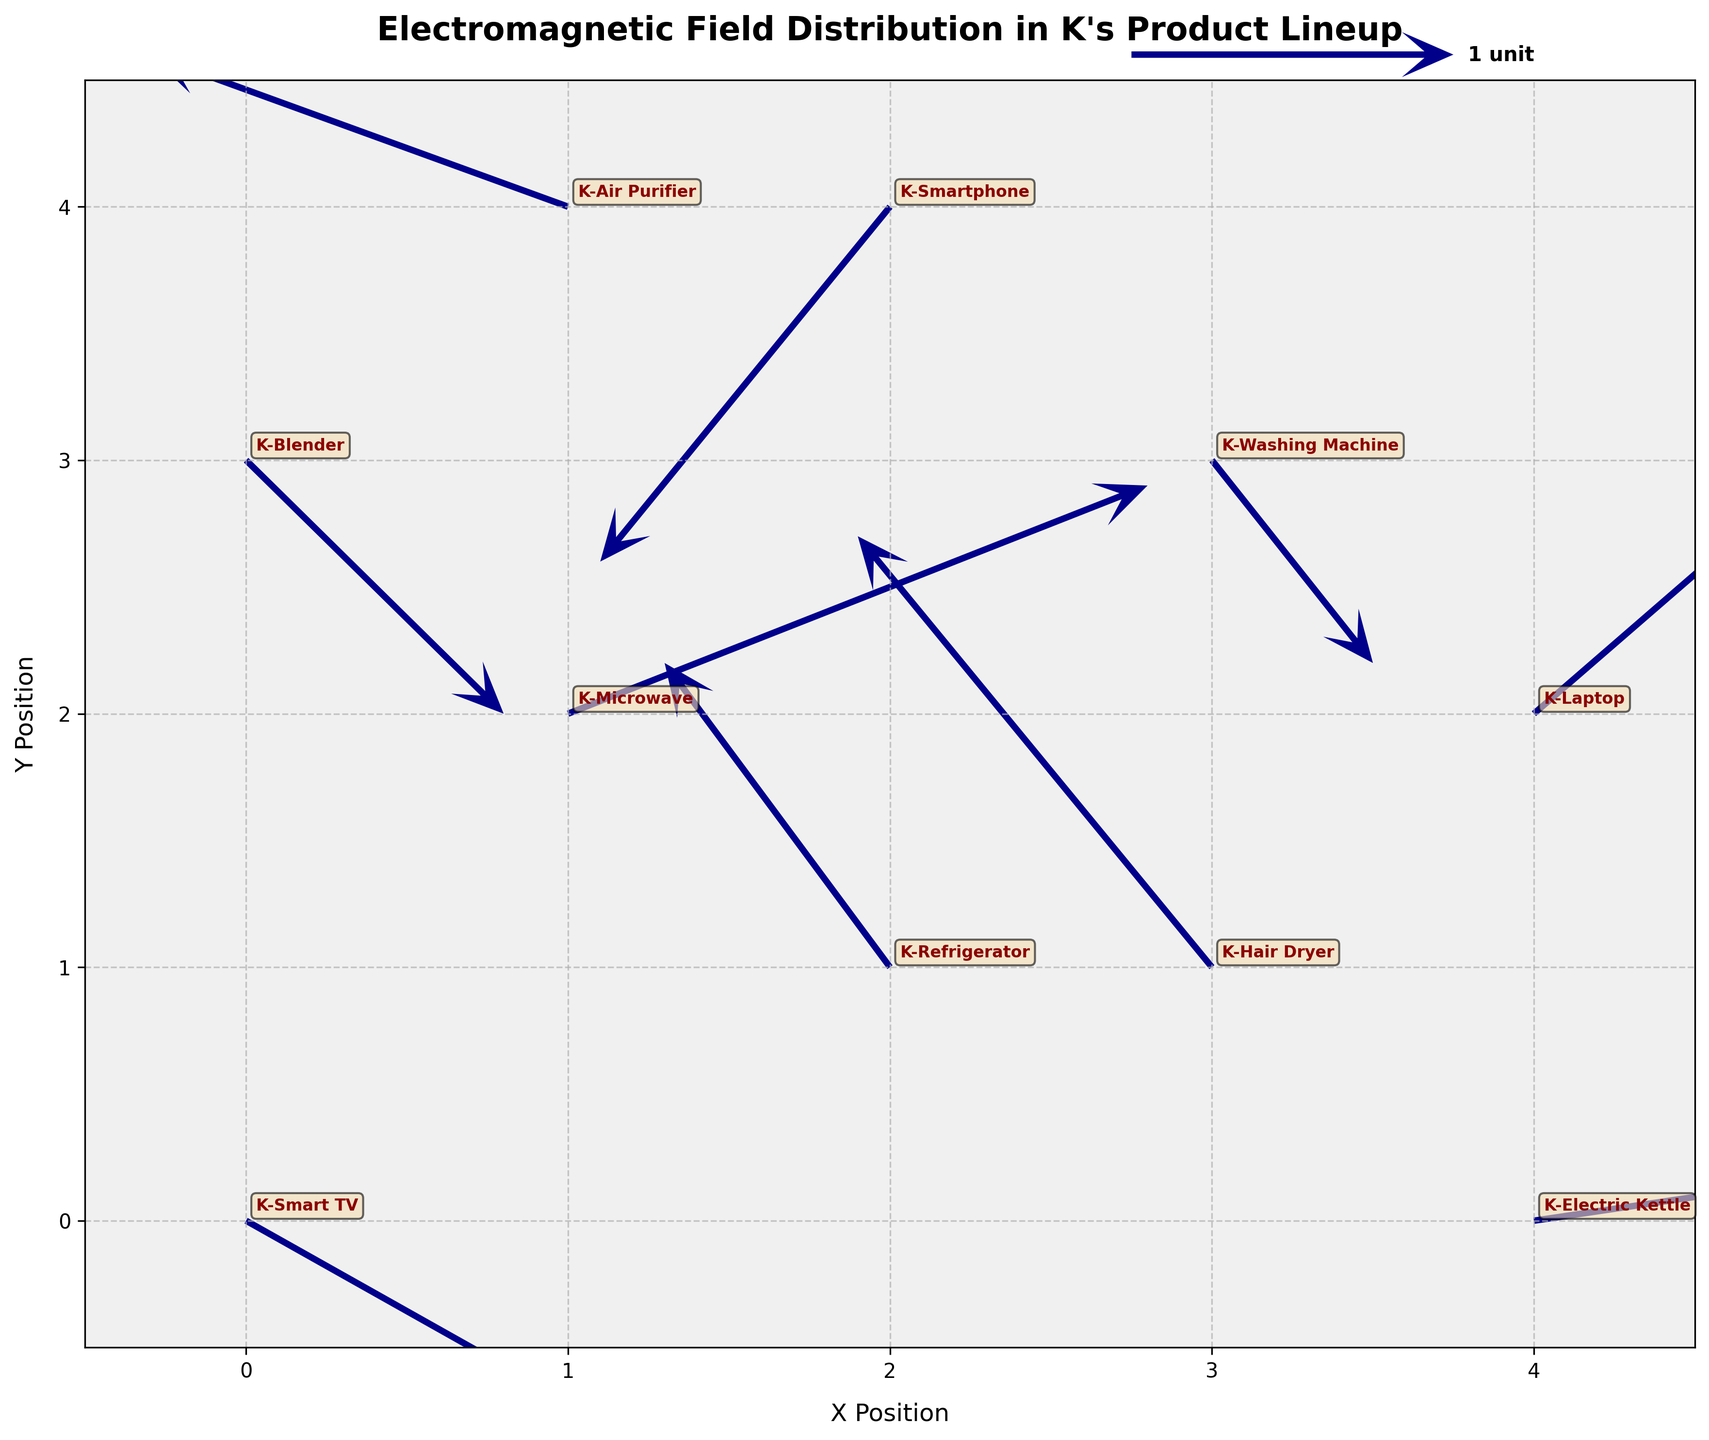Which product has the most prominent vector (the longest arrow)? To determine the product with the longest arrow, visually inspect the figure for the lengthiest vector. The longest arrow is associated with the product that has the greatest electromagnetic field magnitude.
Answer: K-Hair Dryer What is the title of the plot? The title of the plot is displayed prominently at the top. It provides an overview of the subject matter depicted.
Answer: Electromagnetic Field Distribution in K's Product Lineup How many products are displayed in the plot? Count the unique products annotated on the plot to determine the total number. Each product has a specific position and vector.
Answer: 10 Which product's electromagnetic field vector points downwards and to the left? Look for arrows that have both negative u and negative v components, indicative of pointing downwards and to the left.
Answer: K-Smartphone What are the x and y position ranges in the plot? Check the x-axis and y-axis limits defined in the plot. Look for the minimum and maximum values on each axis.
Answer: (-0.5, 4.5) for both axes Which product has an electromagnetic vector that points primarily upwards? Identify the vector that has a significant positive v value and minimal positive u value denoting upward direction.
Answer: K-Hair Dryer Compare the electromagnetic field vectors of K-Microwave and K-Washing Machine. Which one is stronger? Calculate the magnitude of vectors for both products using the formula √(u² + v²) and compare them.
Answer: K-Microwave What is the length of the vector for K-Refrigerator? Calculate the magnitude of the K-Refrigerator vector using the formula √(u² + v²), substituting the given components.
Answer: 1.37 Which products' vectors have a significant impact in the positive x-direction? Look for vectors with substantial positive u components, indicating a force in the positive x-direction.
Answer: K-Smart TV, K-Microwave, K-Electric Kettle Which product is positioned at coordinates (4, 0)? Find the annotation directly on coordinates (4, 0), as each product label corresponds to its position in the plot.
Answer: K-Electric Kettle 